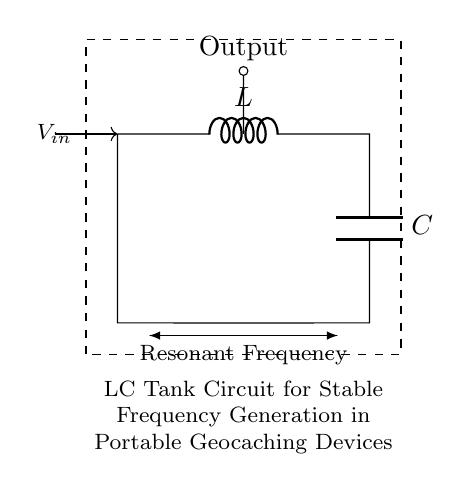What is the inductor designated as in this circuit? The inductor is labeled as "L" in the circuit diagram, which is a standard representation in electrical schematics.
Answer: L What component connects the inductor and capacitor? The circuit shows a direct connection (short line) between the inductor and capacitor, indicating they are linked in the LC tank circuit.
Answer: short What is the purpose of this LC tank circuit? The description in the diagram states that it is for stable frequency generation, which implies its use in maintaining a consistent oscillation output.
Answer: stable frequency generation What type of circuit is depicted in the diagram? The diagram features an LC tank circuit which consists of an inductor and capacitor, known for resonating at a specific frequency.
Answer: LC tank circuit How does the resonant frequency relate to the inductor and capacitor values? The resonant frequency is determined by the values of the inductor (L) and capacitor (C), as \( f_0 = \frac{1}{2\pi\sqrt{LC}} \), reflecting the relationship between these components.
Answer: inverse square root of LC What is the output point for this circuit? The output is indicated by a node labeled "Output" in the circuit, where the signal would be taken from the resonating LC components.
Answer: Output What type of frequency does this circuit generate? The LC circuit generates a resonant frequency, highlighting its use in applications such as oscillators or in tuning circuits.
Answer: resonant frequency 